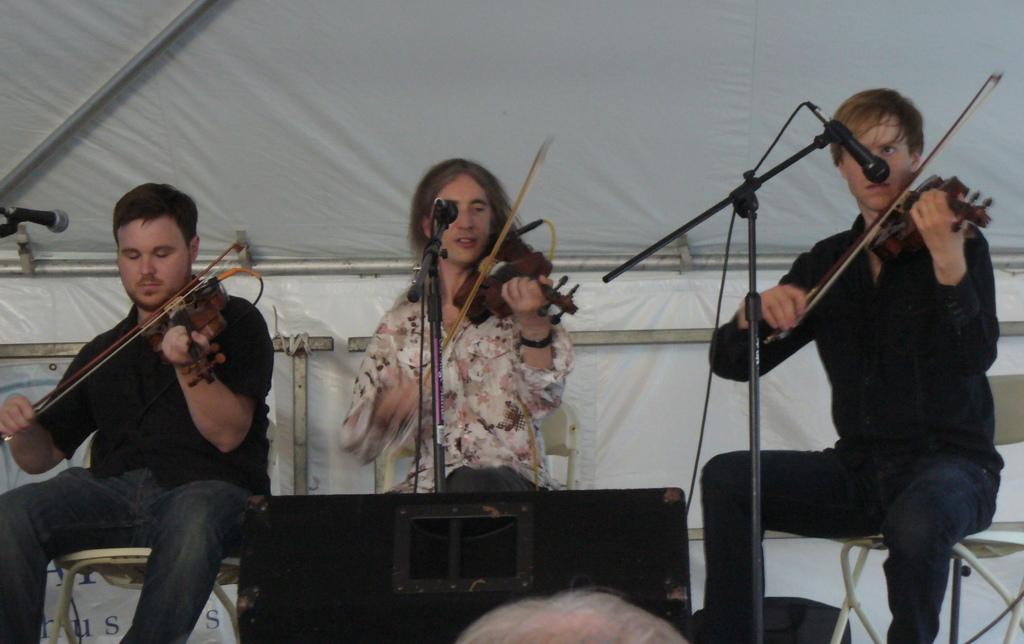How many people are in the image? There are three people in the image. What are the people doing in the image? The people are sitting on chairs and holding violins in their hands. How many babies are in the image? There are no babies present in the image. 